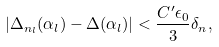Convert formula to latex. <formula><loc_0><loc_0><loc_500><loc_500>| \Delta _ { n _ { l } } ( \alpha _ { l } ) - \Delta ( \alpha _ { l } ) | < \frac { C ^ { \prime } \epsilon _ { 0 } } { 3 } \delta _ { n } ,</formula> 